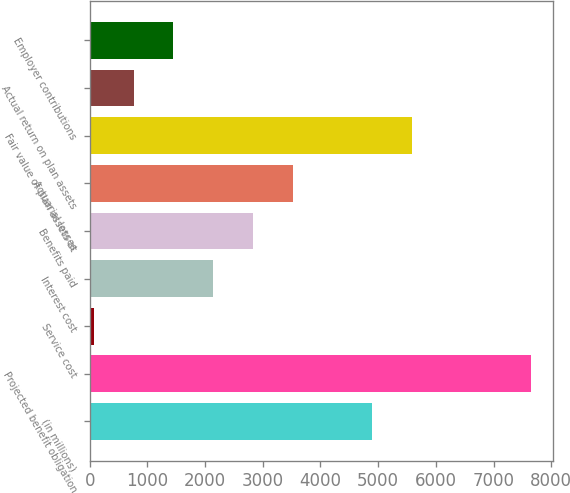Convert chart to OTSL. <chart><loc_0><loc_0><loc_500><loc_500><bar_chart><fcel>(in millions)<fcel>Projected benefit obligation<fcel>Service cost<fcel>Interest cost<fcel>Benefits paid<fcel>Actuarial losses<fcel>Fair value of plan assets at<fcel>Actual return on plan assets<fcel>Employer contributions<nl><fcel>4897.7<fcel>7654.1<fcel>74<fcel>2141.3<fcel>2830.4<fcel>3519.5<fcel>5586.8<fcel>763.1<fcel>1452.2<nl></chart> 